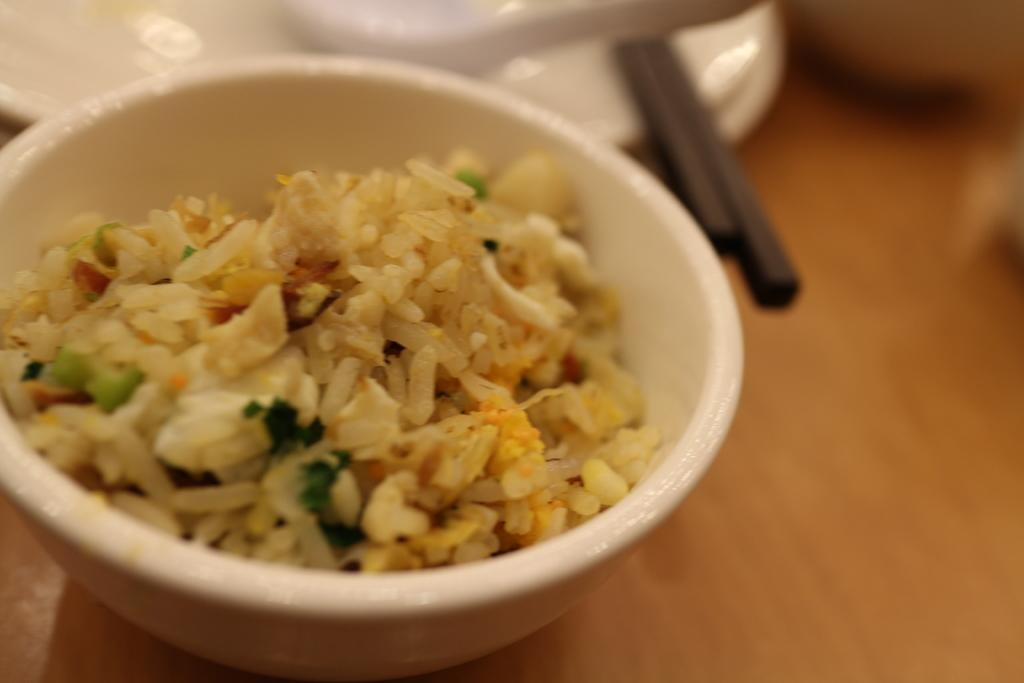What piece of furniture is present in the image? There is a table in the image. What utensils can be seen on the table? Chopsticks, plates, and spoons are visible on the table. What type of food is in the bowl on the table? There is a bowl of rice on the table. What direction is the coach heading in the image? There is no coach present in the image. Can you tell me what the person is writing in their notebook in the image? There is no notebook or person writing in the image. 